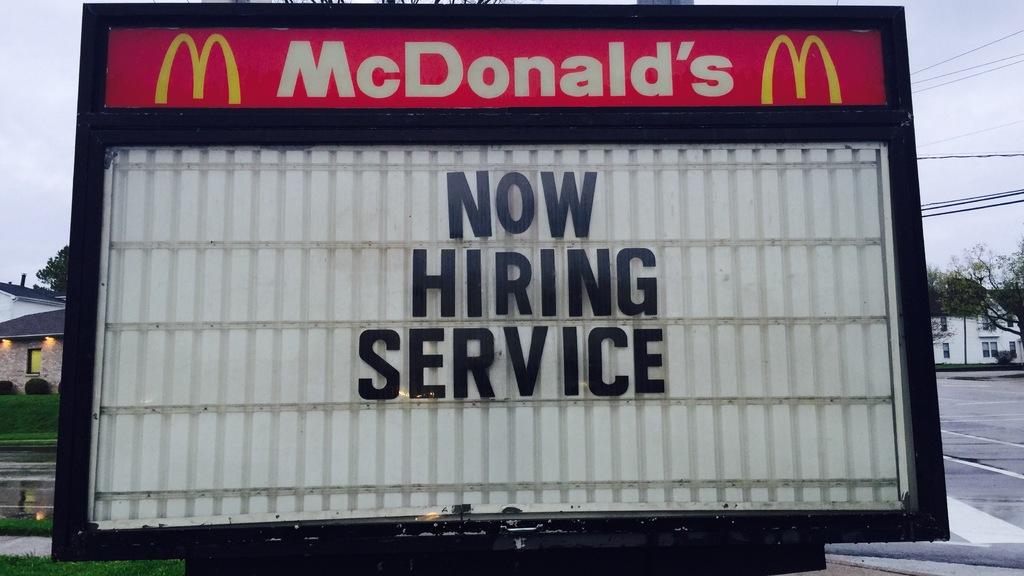What is mcdonald's hiring for?
Provide a short and direct response. Service. What is the name of the business?
Provide a succinct answer. Mcdonalds. 